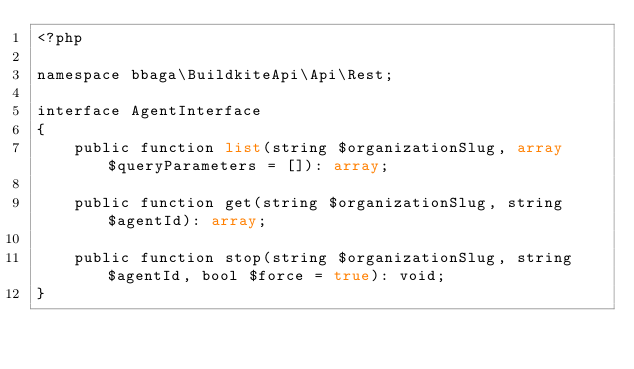Convert code to text. <code><loc_0><loc_0><loc_500><loc_500><_PHP_><?php

namespace bbaga\BuildkiteApi\Api\Rest;

interface AgentInterface
{
    public function list(string $organizationSlug, array $queryParameters = []): array;

    public function get(string $organizationSlug, string $agentId): array;

    public function stop(string $organizationSlug, string $agentId, bool $force = true): void;
}
</code> 